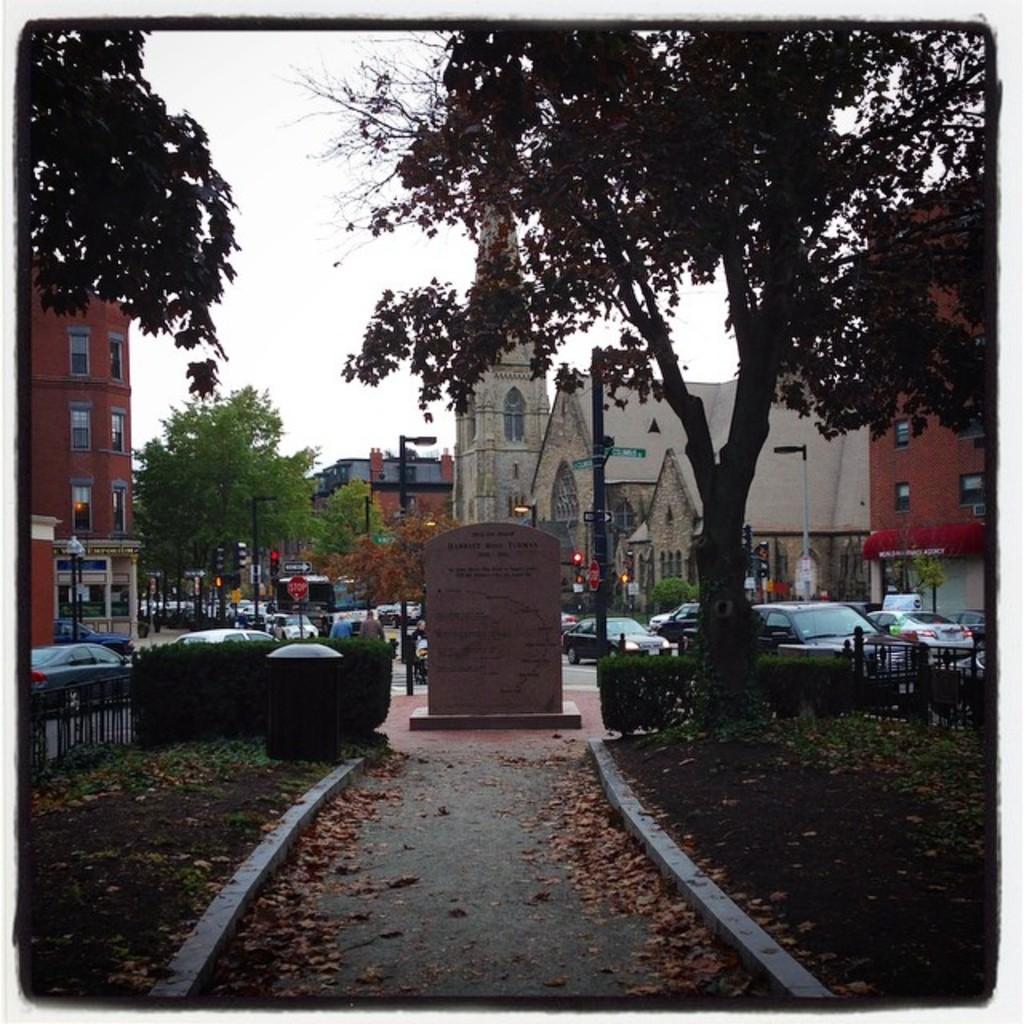Can you describe this image briefly? In this image we can see a walkway. Near to that there is a small wall with something written. Also there are leaves on the ground. And there is a bin. There are bushes. In the back there are buildings. Also there are trees. And there are many vehicles. And we can see traffic signals. In the background there is sky. 